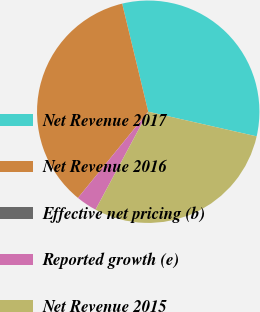Convert chart to OTSL. <chart><loc_0><loc_0><loc_500><loc_500><pie_chart><fcel>Net Revenue 2017<fcel>Net Revenue 2016<fcel>Effective net pricing (b)<fcel>Reported growth (e)<fcel>Net Revenue 2015<nl><fcel>32.32%<fcel>35.35%<fcel>0.0%<fcel>3.03%<fcel>29.3%<nl></chart> 